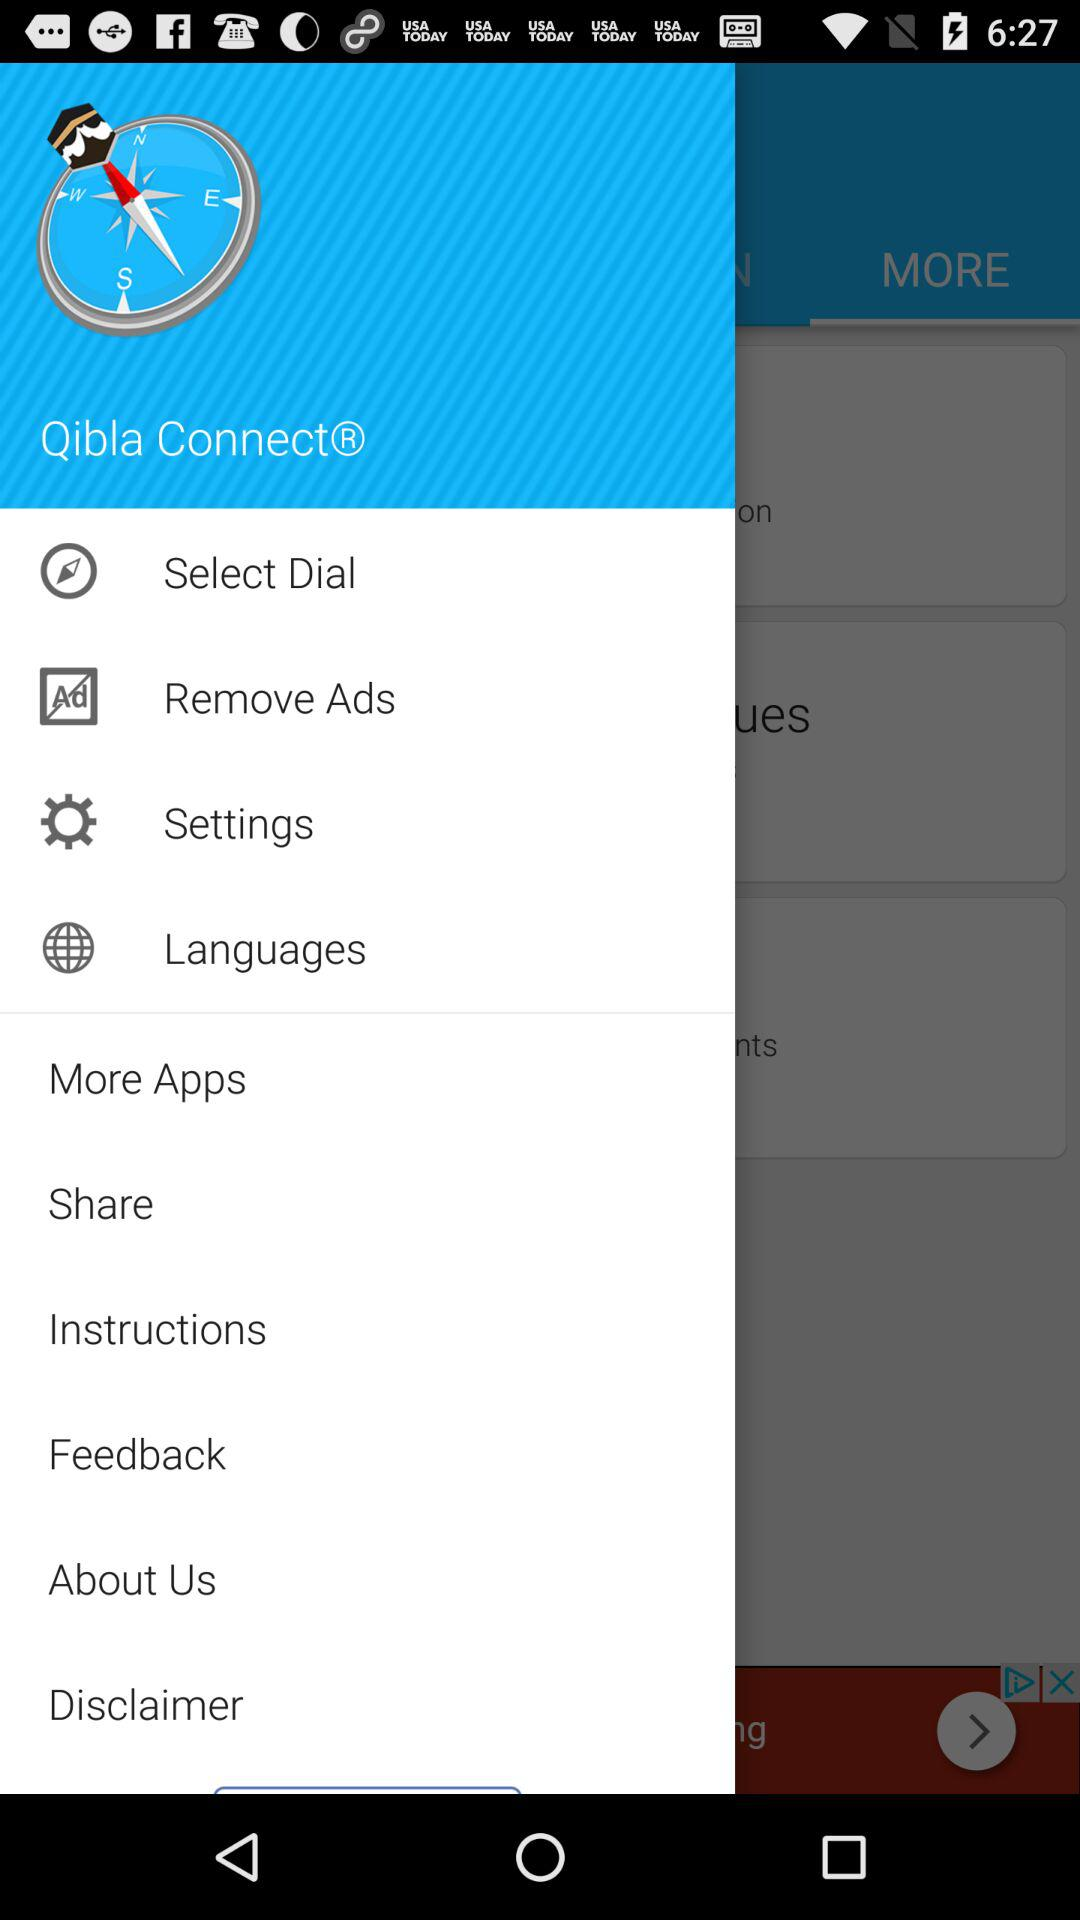What is the application name? The application name is "Qibla Connect". 